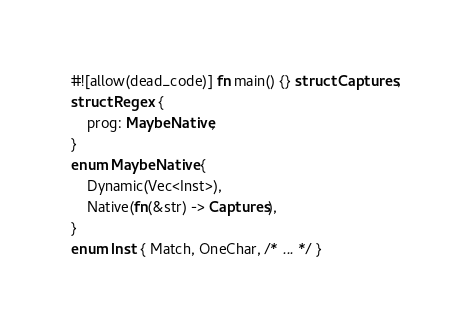<code> <loc_0><loc_0><loc_500><loc_500><_Rust_>#![allow(dead_code)] fn main() {} struct Captures;
struct Regex {
    prog: MaybeNative,
}
enum MaybeNative {
    Dynamic(Vec<Inst>),
    Native(fn(&str) -> Captures),
}
enum Inst { Match, OneChar, /* ... */ }
</code> 